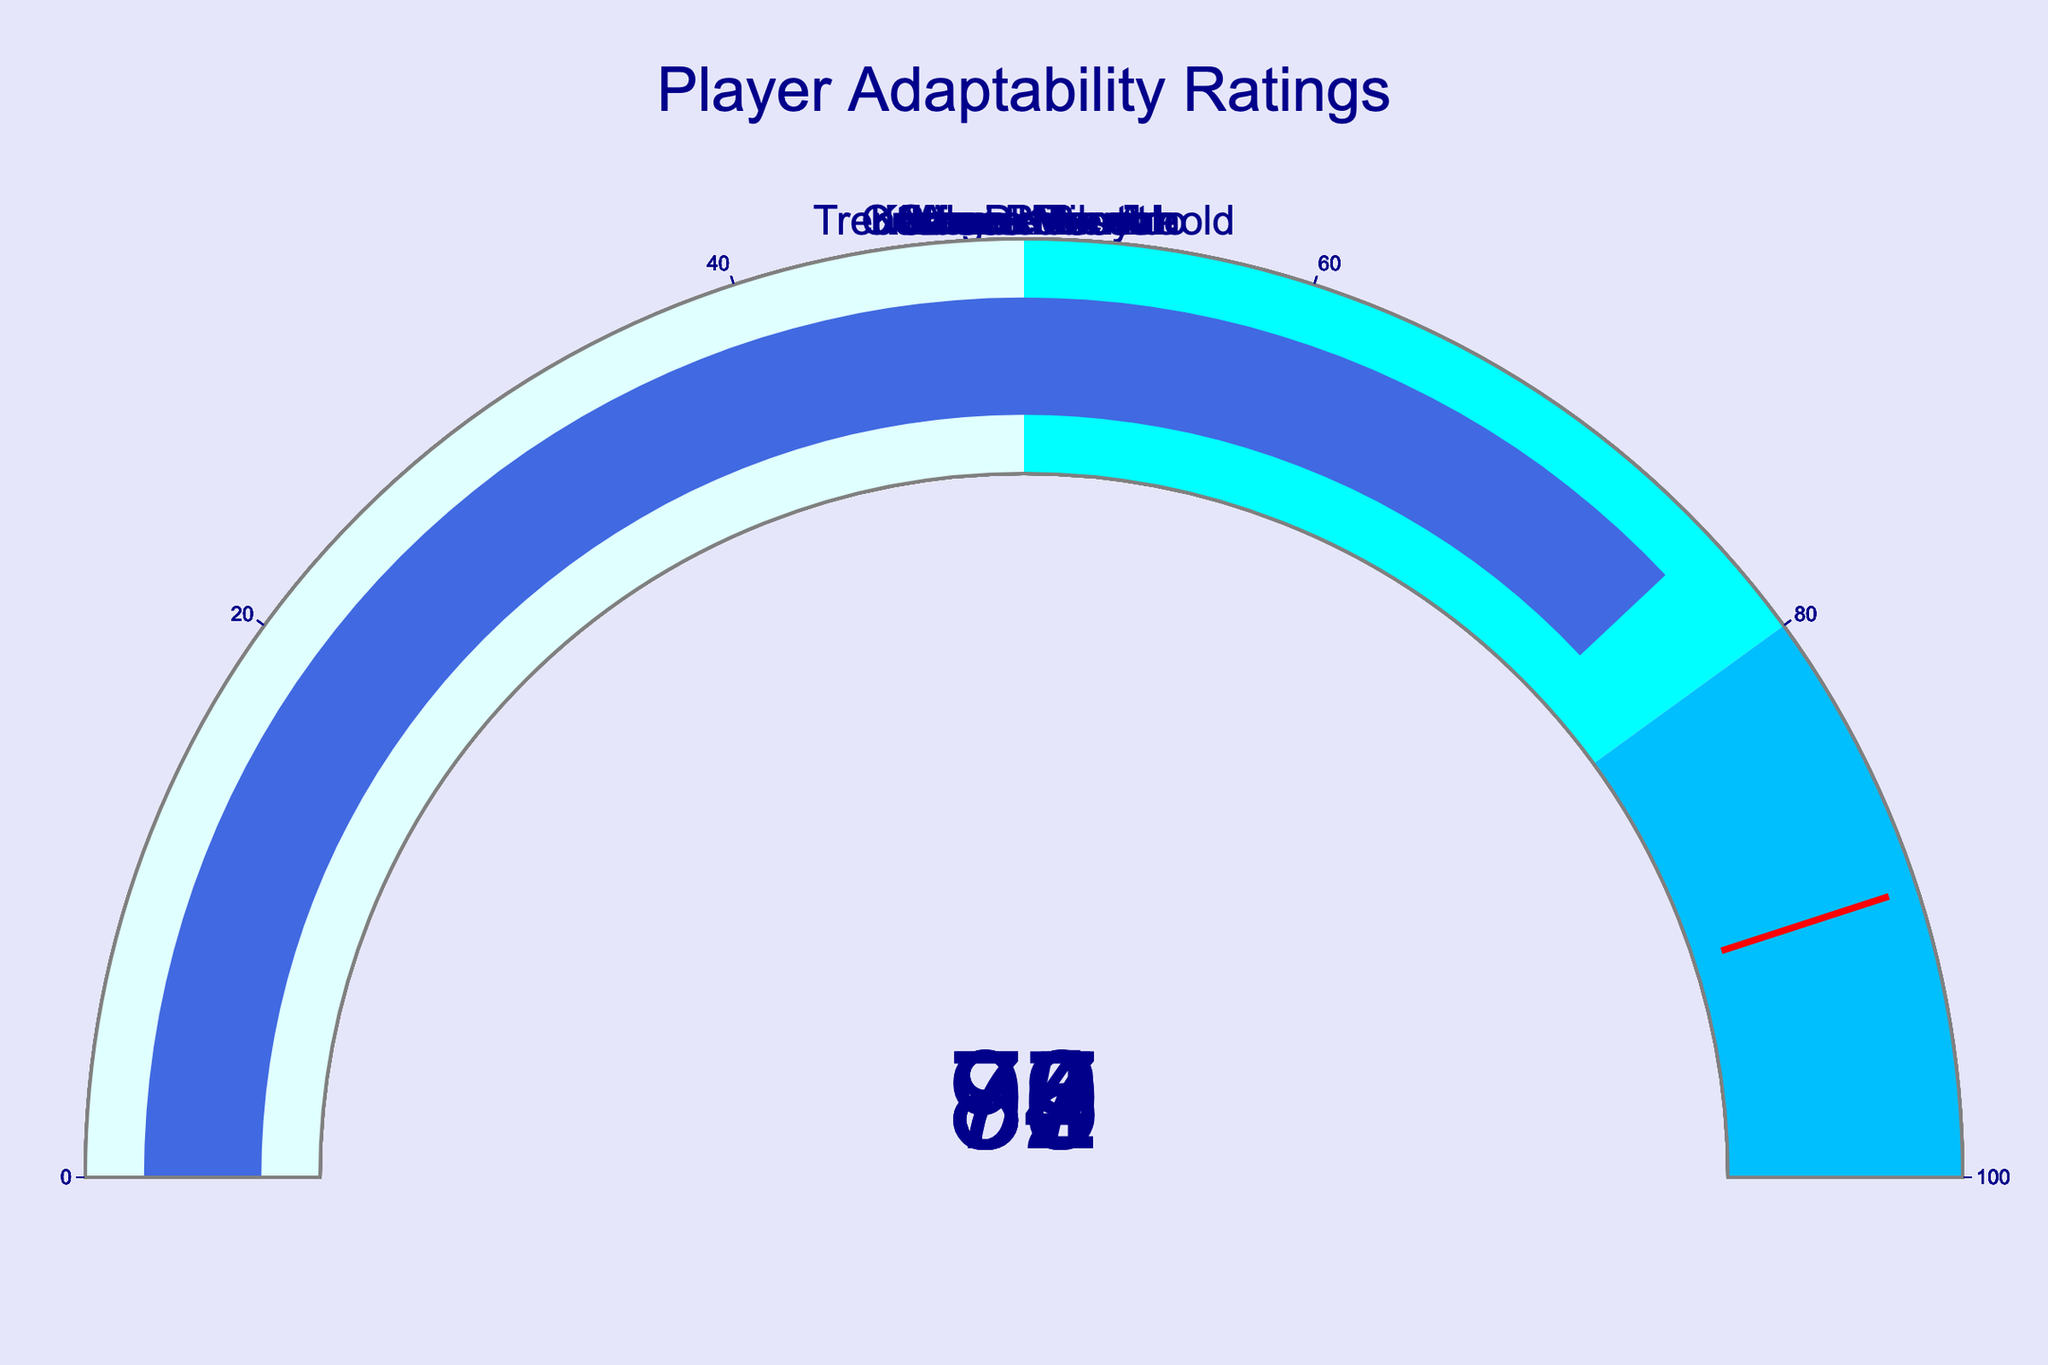what is the adaptability rating of Cristiano Ronaldo? Look at the gauge labeled "Cristiano Ronaldo" and find the number displayed on it.
Answer: 95 Which player has the highest adaptability rating? Compare the numbers on all the gauges and identify the highest number. Cristiano Ronaldo has the highest rating at 95.
Answer: Cristiano Ronaldo What's the total adaptability rating of Lionel Messi and Joshua Kimmich? Add the adaptability ratings of Lionel Messi (92) and Joshua Kimmich (89). 92 + 89 = 181
Answer: 181 Which players have an adaptability rating above 90? Identify the gauges with numbers above 90. Cristiano Ronaldo (95) and Lionel Messi (92) have ratings above 90.
Answer: Cristiano Ronaldo, Lionel Messi What is the average adaptability rating of all players? Add the adaptability ratings of all players and divide by the number of players: (95 + 92 + 89 + 87 + 84 + 82 + 79 + 76) / 8 = 684 / 8 = 85.5
Answer: 85.5 What color is the bar on the gauge for Trent Alexander-Arnold? Observe the color of the bar on his gauge. The gauge for Trent Alexander-Arnold has a bar color of royal blue.
Answer: royal blue Who has a higher adaptability rating, Kevin De Bruyne or Mason Mount? Compare the numbers on the gauges of Kevin De Bruyne (82) and Mason Mount (76). Kevin De Bruyne has a higher rating.
Answer: Kevin De Bruyne How many players have an adaptability rating below 80? Count the gauges with numbers less than 80. Only Mason Mount and Trent Alexander-Arnold fall into this category.
Answer: 2 What's the difference in adaptability rating between James Milner and Sergi Roberto? Subtract the adaptability rating of Sergi Roberto (84) from James Milner (87). 87 - 84 = 3
Answer: 3 Which threshold value is shown on the gauges? The threshold value line on all the gauges is 90.
Answer: 90 